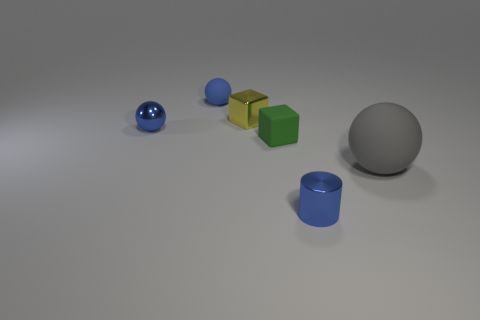The rubber sphere that is on the right side of the small blue thing right of the small matte object that is behind the tiny yellow shiny block is what color?
Keep it short and to the point. Gray. Is the shape of the small yellow thing the same as the large gray object?
Your response must be concise. No. Are there an equal number of metallic balls left of the shiny block and yellow metal blocks?
Ensure brevity in your answer.  Yes. What number of other objects are there of the same material as the tiny green object?
Offer a very short reply. 2. Is the size of the blue sphere that is in front of the tiny yellow shiny object the same as the blue shiny thing in front of the gray rubber sphere?
Ensure brevity in your answer.  Yes. What number of things are either metal things behind the big ball or metallic things behind the small blue metal cylinder?
Make the answer very short. 2. Are there any other things that have the same shape as the tiny green object?
Your response must be concise. Yes. Do the small rubber thing that is behind the small green block and the metallic object that is in front of the large rubber sphere have the same color?
Give a very brief answer. Yes. What number of matte things are either yellow cylinders or blue cylinders?
Give a very brief answer. 0. Are there any other things that are the same size as the gray sphere?
Provide a short and direct response. No. 